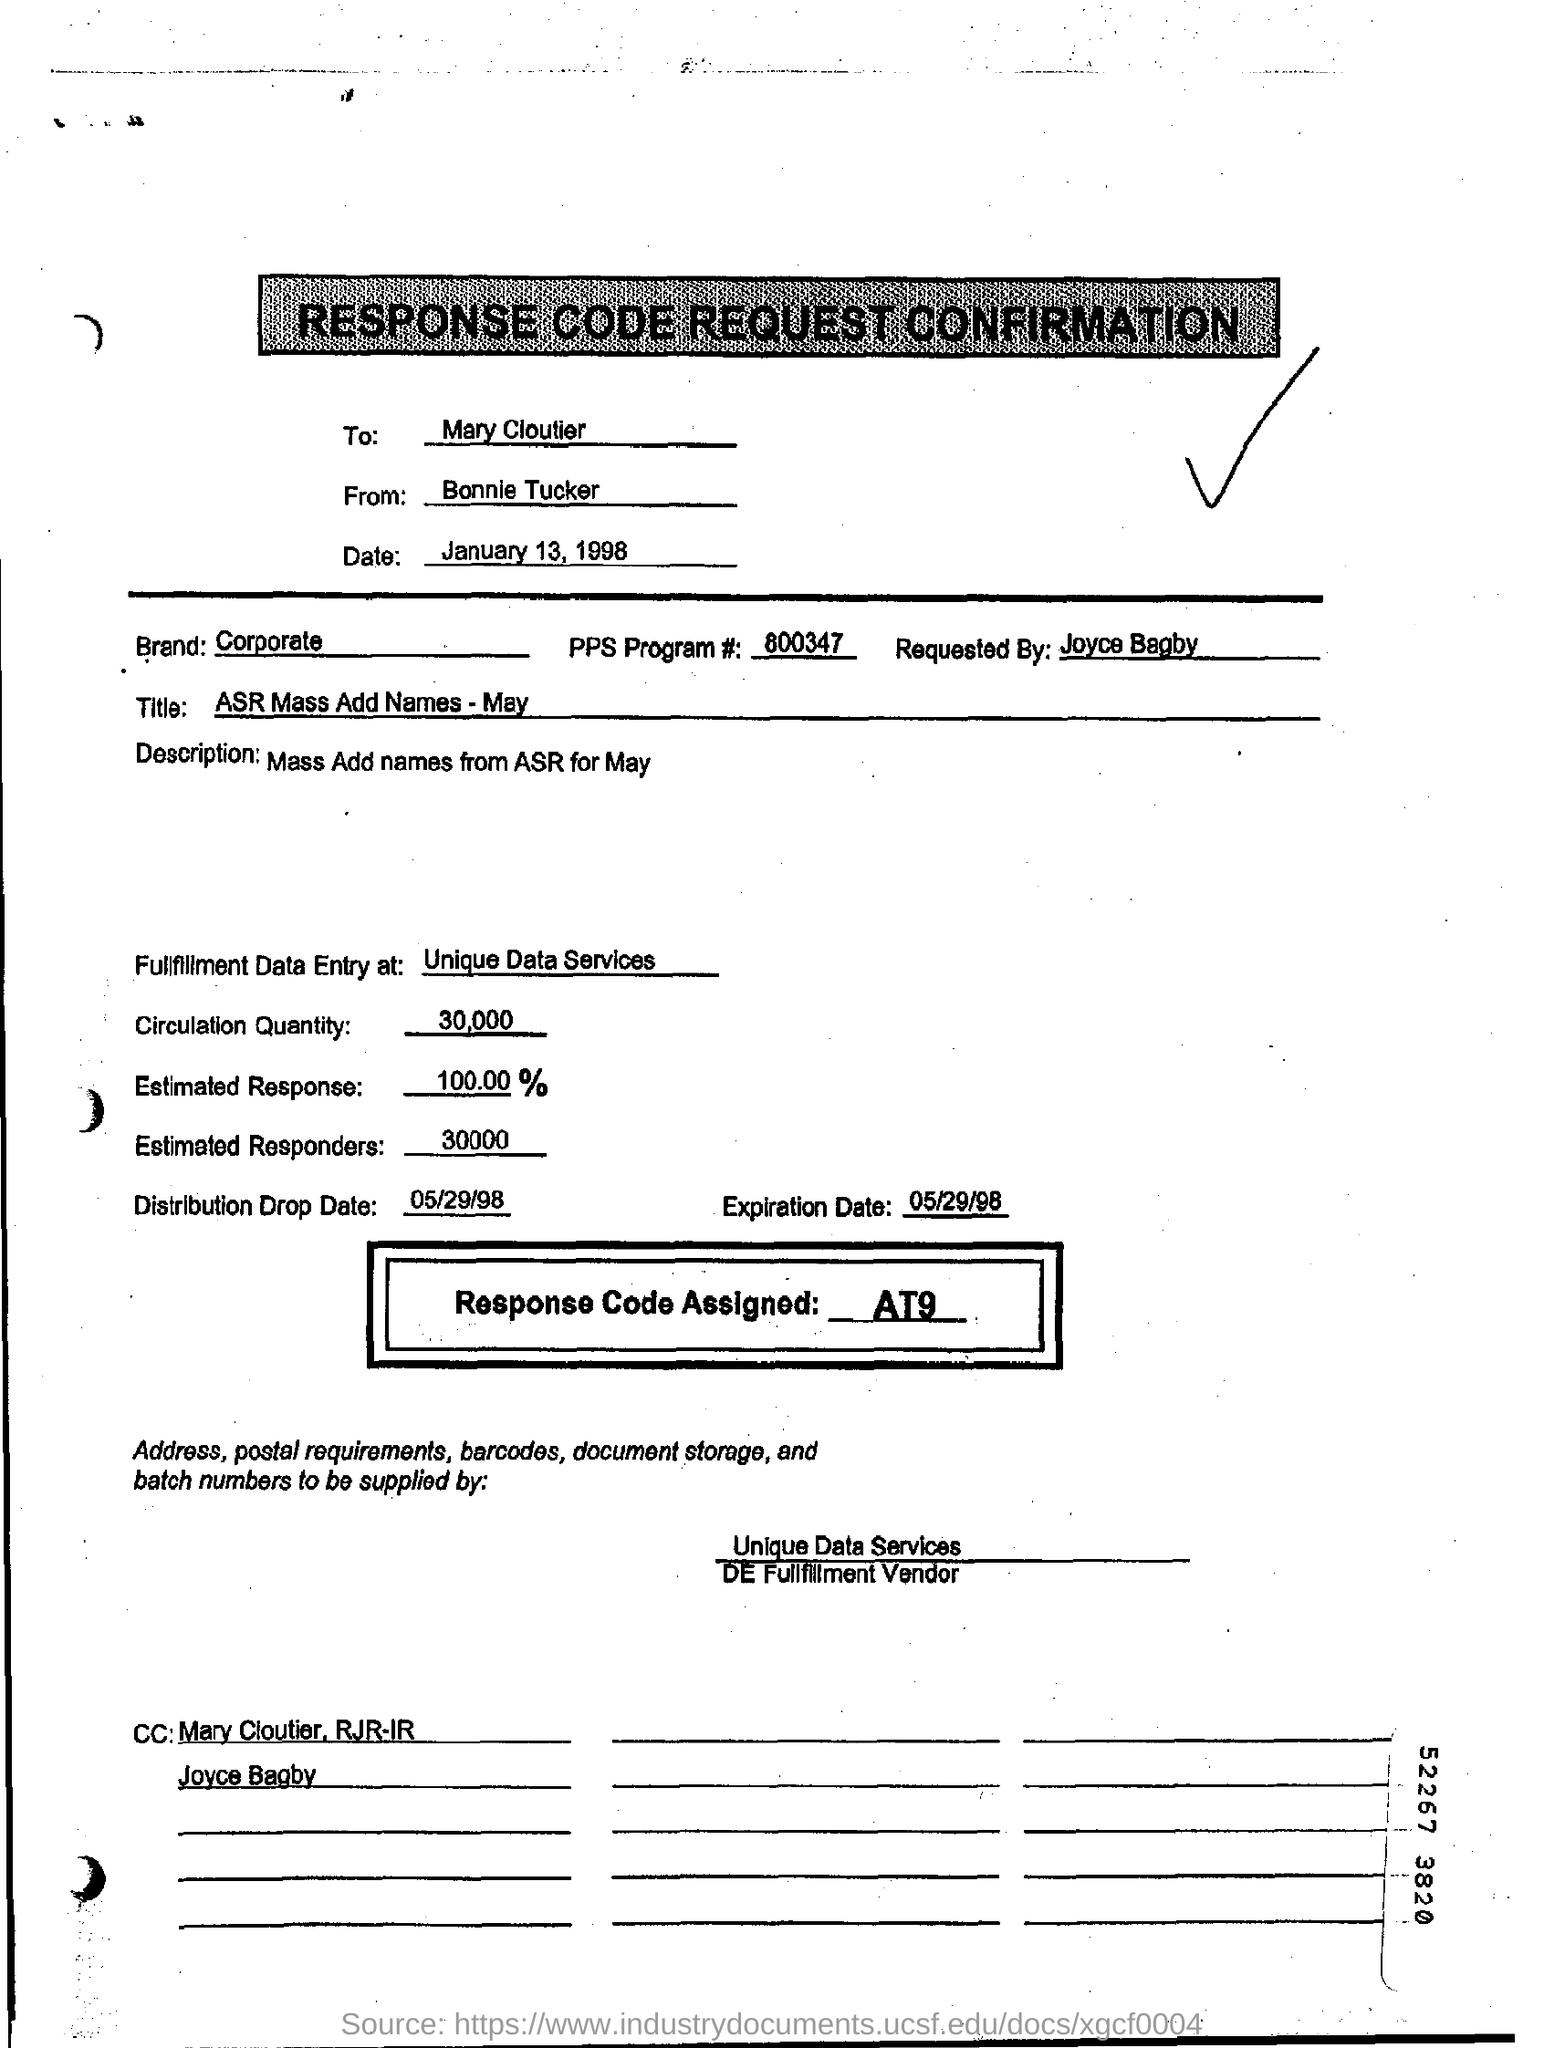What kind of document is this?
Keep it short and to the point. RESPONSE CODE REQUEST CONFIRMATION. What is the Expiration date mentioned in this document?
Your response must be concise. 05/29/98. Who is the sender of the document?
Provide a short and direct response. Bonnie Tucker. Who is the receiver of the document?
Your answer should be compact. Mary Cloutier. What is the Response Code Assigned?
Your response must be concise. At9. What is the Circulation Quantity as per the document?
Provide a short and direct response. 30000. What percent is the Estimated Response?
Offer a terse response. 100.00 %. 